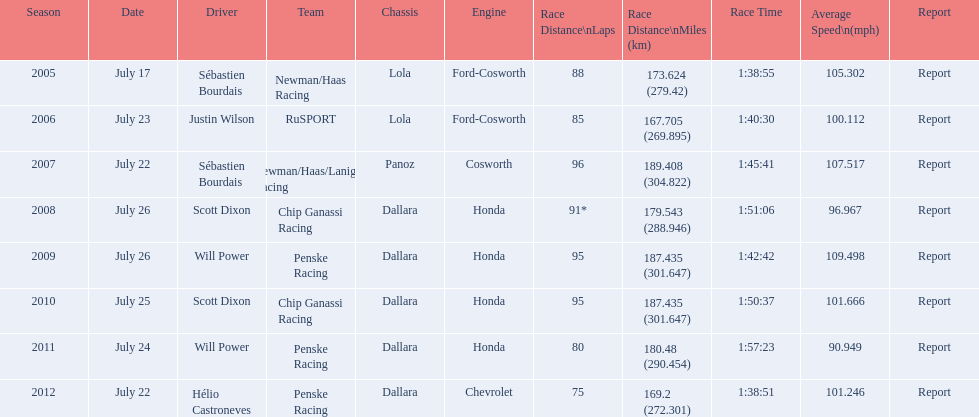Prior to rusport's victory, which team emerged as the winner in the champ car world series? Newman/Haas Racing. 